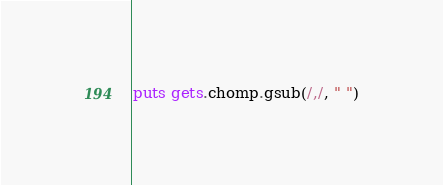Convert code to text. <code><loc_0><loc_0><loc_500><loc_500><_Ruby_>puts gets.chomp.gsub(/,/, " ")
</code> 